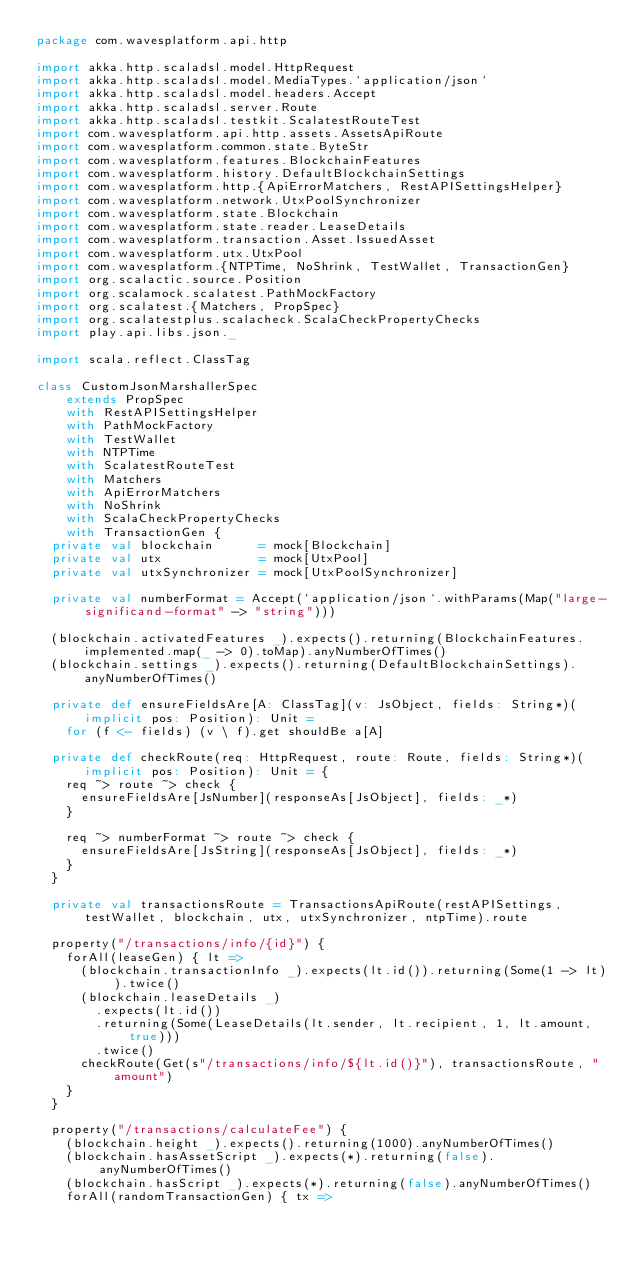<code> <loc_0><loc_0><loc_500><loc_500><_Scala_>package com.wavesplatform.api.http

import akka.http.scaladsl.model.HttpRequest
import akka.http.scaladsl.model.MediaTypes.`application/json`
import akka.http.scaladsl.model.headers.Accept
import akka.http.scaladsl.server.Route
import akka.http.scaladsl.testkit.ScalatestRouteTest
import com.wavesplatform.api.http.assets.AssetsApiRoute
import com.wavesplatform.common.state.ByteStr
import com.wavesplatform.features.BlockchainFeatures
import com.wavesplatform.history.DefaultBlockchainSettings
import com.wavesplatform.http.{ApiErrorMatchers, RestAPISettingsHelper}
import com.wavesplatform.network.UtxPoolSynchronizer
import com.wavesplatform.state.Blockchain
import com.wavesplatform.state.reader.LeaseDetails
import com.wavesplatform.transaction.Asset.IssuedAsset
import com.wavesplatform.utx.UtxPool
import com.wavesplatform.{NTPTime, NoShrink, TestWallet, TransactionGen}
import org.scalactic.source.Position
import org.scalamock.scalatest.PathMockFactory
import org.scalatest.{Matchers, PropSpec}
import org.scalatestplus.scalacheck.ScalaCheckPropertyChecks
import play.api.libs.json._

import scala.reflect.ClassTag

class CustomJsonMarshallerSpec
    extends PropSpec
    with RestAPISettingsHelper
    with PathMockFactory
    with TestWallet
    with NTPTime
    with ScalatestRouteTest
    with Matchers
    with ApiErrorMatchers
    with NoShrink
    with ScalaCheckPropertyChecks
    with TransactionGen {
  private val blockchain      = mock[Blockchain]
  private val utx             = mock[UtxPool]
  private val utxSynchronizer = mock[UtxPoolSynchronizer]

  private val numberFormat = Accept(`application/json`.withParams(Map("large-significand-format" -> "string")))

  (blockchain.activatedFeatures _).expects().returning(BlockchainFeatures.implemented.map(_ -> 0).toMap).anyNumberOfTimes()
  (blockchain.settings _).expects().returning(DefaultBlockchainSettings).anyNumberOfTimes()

  private def ensureFieldsAre[A: ClassTag](v: JsObject, fields: String*)(implicit pos: Position): Unit =
    for (f <- fields) (v \ f).get shouldBe a[A]

  private def checkRoute(req: HttpRequest, route: Route, fields: String*)(implicit pos: Position): Unit = {
    req ~> route ~> check {
      ensureFieldsAre[JsNumber](responseAs[JsObject], fields: _*)
    }

    req ~> numberFormat ~> route ~> check {
      ensureFieldsAre[JsString](responseAs[JsObject], fields: _*)
    }
  }

  private val transactionsRoute = TransactionsApiRoute(restAPISettings, testWallet, blockchain, utx, utxSynchronizer, ntpTime).route

  property("/transactions/info/{id}") {
    forAll(leaseGen) { lt =>
      (blockchain.transactionInfo _).expects(lt.id()).returning(Some(1 -> lt)).twice()
      (blockchain.leaseDetails _)
        .expects(lt.id())
        .returning(Some(LeaseDetails(lt.sender, lt.recipient, 1, lt.amount, true)))
        .twice()
      checkRoute(Get(s"/transactions/info/${lt.id()}"), transactionsRoute, "amount")
    }
  }

  property("/transactions/calculateFee") {
    (blockchain.height _).expects().returning(1000).anyNumberOfTimes()
    (blockchain.hasAssetScript _).expects(*).returning(false).anyNumberOfTimes()
    (blockchain.hasScript _).expects(*).returning(false).anyNumberOfTimes()
    forAll(randomTransactionGen) { tx =></code> 